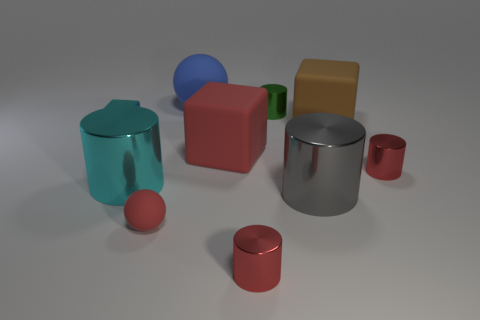Does the small metallic block have the same color as the big cylinder that is behind the gray metal cylinder?
Ensure brevity in your answer.  Yes. How many cubes have the same color as the tiny ball?
Ensure brevity in your answer.  1. There is a ball that is the same size as the cyan shiny block; what is it made of?
Your answer should be compact. Rubber. How many things are there?
Provide a succinct answer. 10. How big is the red shiny cylinder that is behind the gray object?
Offer a very short reply. Small. Is the number of large matte things behind the big brown block the same as the number of small green balls?
Ensure brevity in your answer.  No. Are there any other large gray matte things that have the same shape as the gray thing?
Give a very brief answer. No. There is a large matte thing that is to the left of the green object and in front of the blue object; what shape is it?
Keep it short and to the point. Cube. Is the brown block made of the same material as the tiny cylinder that is behind the tiny cyan metallic block?
Offer a terse response. No. Are there any big cyan cylinders right of the cyan shiny cube?
Your answer should be very brief. Yes. 